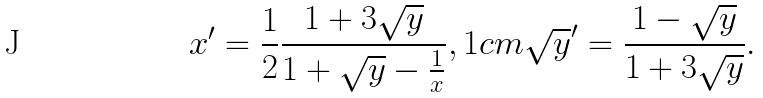Convert formula to latex. <formula><loc_0><loc_0><loc_500><loc_500>x ^ { \prime } = \frac { 1 } { 2 } \frac { 1 + 3 \sqrt { y } } { 1 + \sqrt { y } - \frac { 1 } { x } } , 1 c m \sqrt { y } ^ { \prime } = \frac { 1 - \sqrt { y } } { 1 + 3 \sqrt { y } } .</formula> 